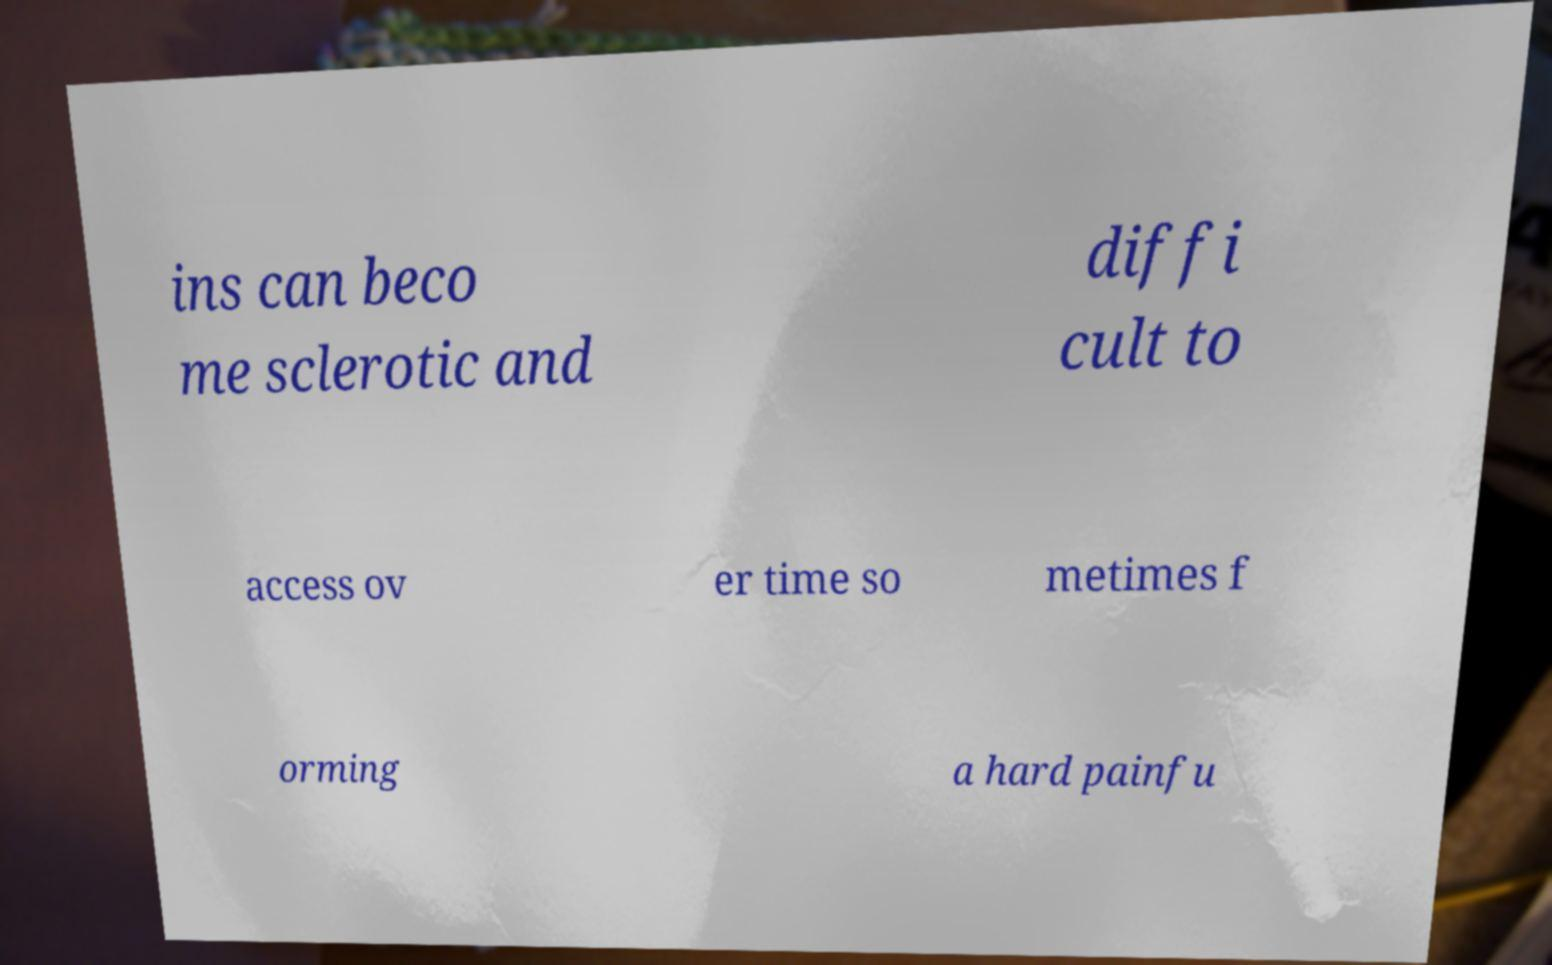Please read and relay the text visible in this image. What does it say? ins can beco me sclerotic and diffi cult to access ov er time so metimes f orming a hard painfu 